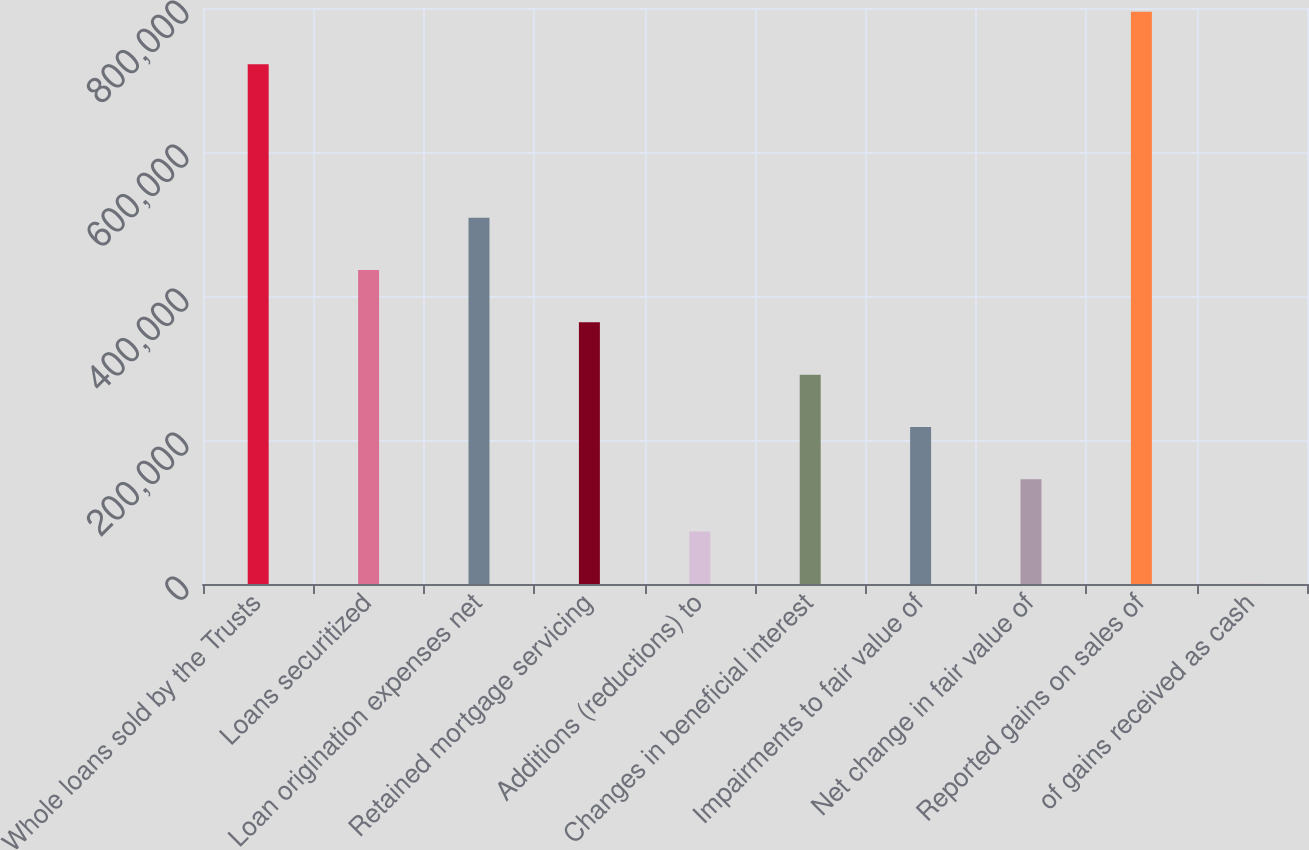<chart> <loc_0><loc_0><loc_500><loc_500><bar_chart><fcel>Whole loans sold by the Trusts<fcel>Loans securitized<fcel>Loan origination expenses net<fcel>Retained mortgage servicing<fcel>Additions (reductions) to<fcel>Changes in beneficial interest<fcel>Impairments to fair value of<fcel>Net change in fair value of<fcel>Reported gains on sales of<fcel>of gains received as cash<nl><fcel>721957<fcel>436066<fcel>508729<fcel>363402<fcel>72750.1<fcel>290739<fcel>218076<fcel>145413<fcel>794620<fcel>87<nl></chart> 